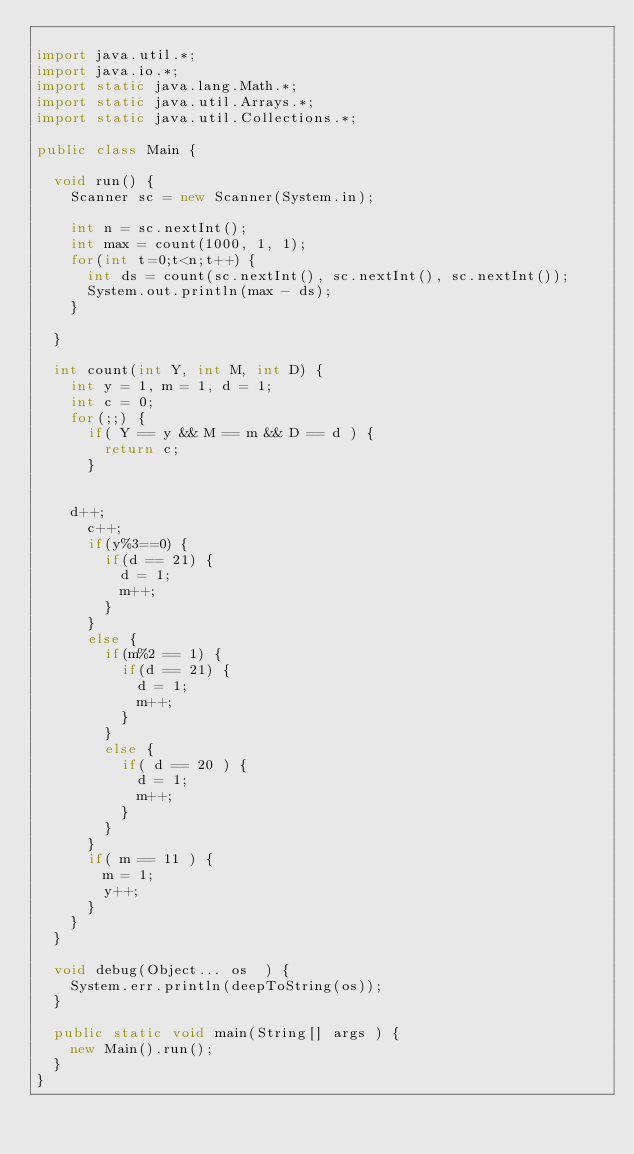Convert code to text. <code><loc_0><loc_0><loc_500><loc_500><_Java_>
import java.util.*;
import java.io.*;
import static java.lang.Math.*;
import static java.util.Arrays.*;
import static java.util.Collections.*;

public class Main {
	
	void run() {
		Scanner sc = new Scanner(System.in);
		
		int n = sc.nextInt();
		int max = count(1000, 1, 1);
		for(int t=0;t<n;t++) {
			int ds = count(sc.nextInt(), sc.nextInt(), sc.nextInt());
			System.out.println(max - ds);
		}
		
	}
	
	int count(int Y, int M, int D) {
		int y = 1, m = 1, d = 1;
		int c = 0;
		for(;;) {
			if( Y == y && M == m && D == d ) {
				return c;
			}
			
	
		d++;
			c++;
			if(y%3==0) {
				if(d == 21) {
					d = 1;
					m++;
				}
			}
			else {
				if(m%2 == 1) {
					if(d == 21) {
						d = 1;
						m++;
					}
				}
				else {
					if( d == 20 ) {
						d = 1;
						m++;
					}
				}
			}
			if( m == 11 ) {
				m = 1;
				y++;
			}
		}
	}
	
	void debug(Object... os  ) {
		System.err.println(deepToString(os));
	}
	
	public static void main(String[] args ) {
		new Main().run();
	}
}</code> 